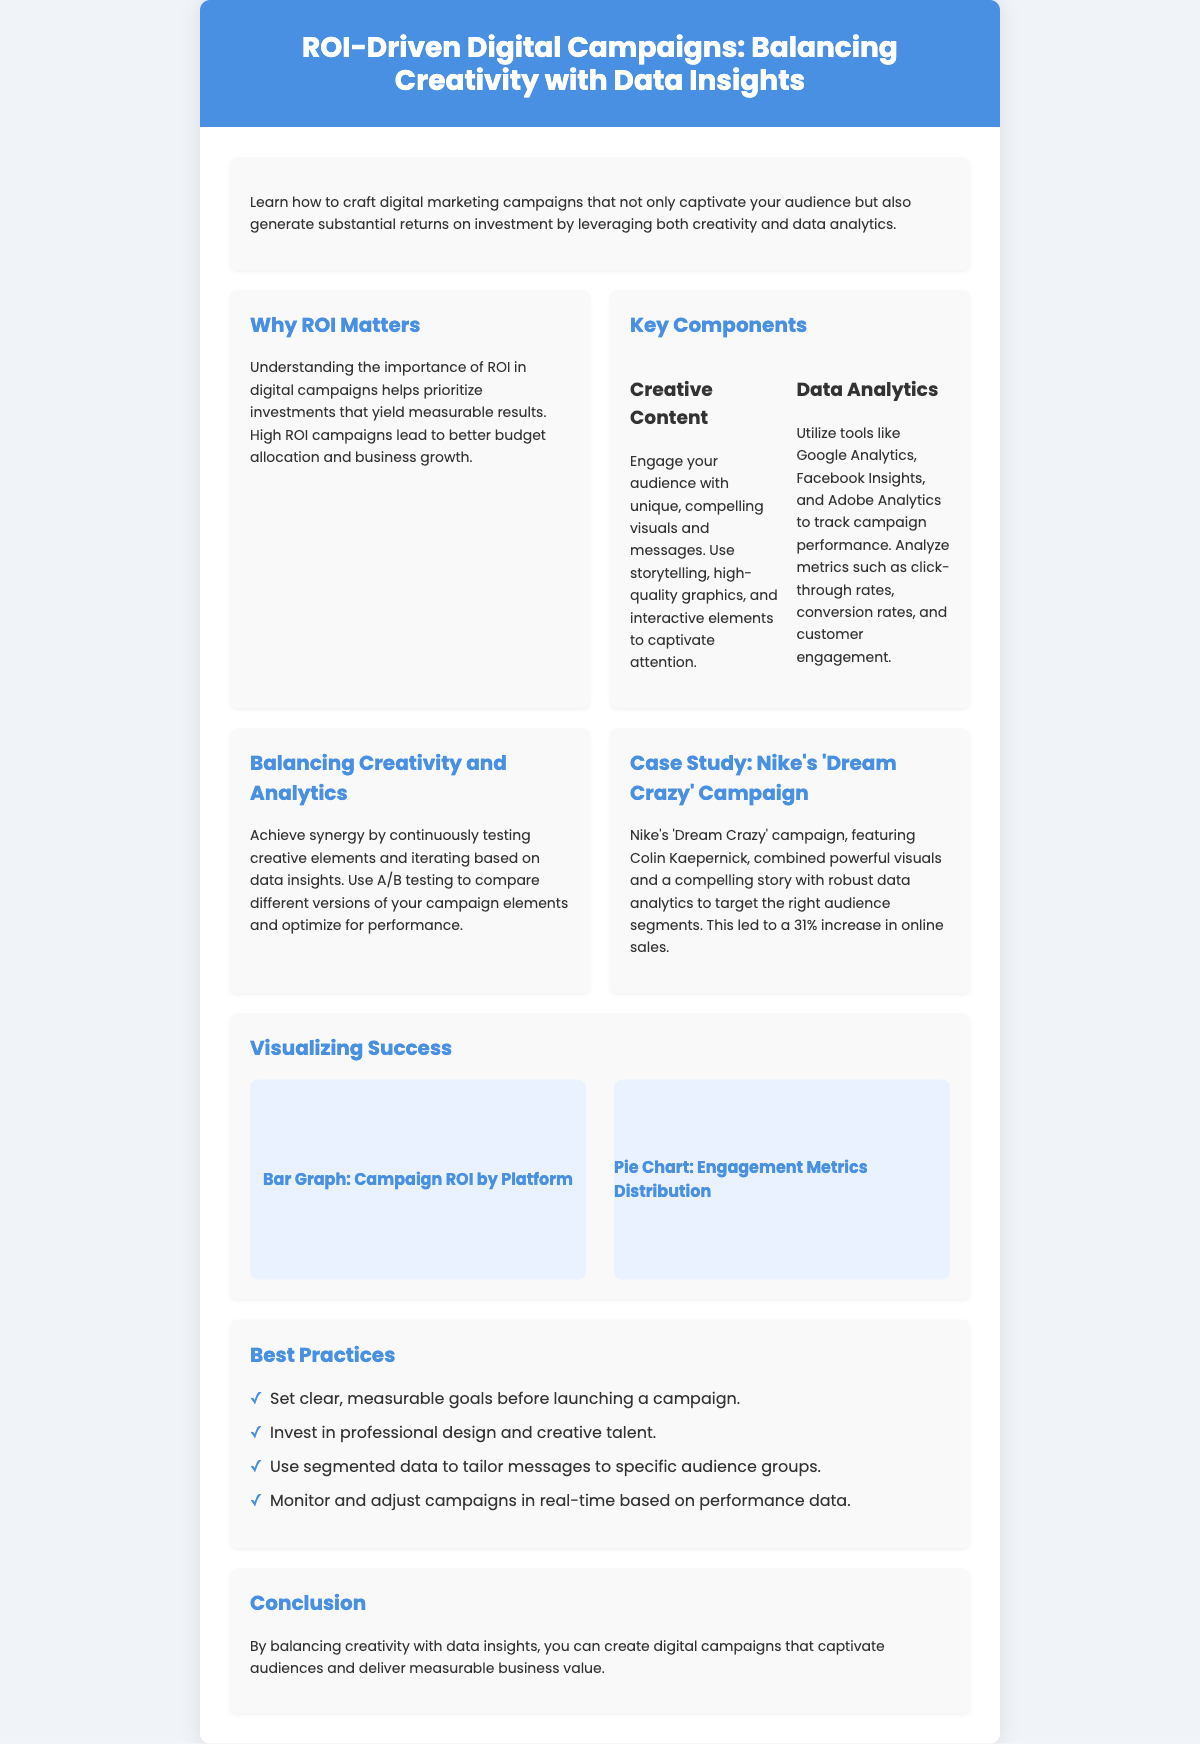What is the title of the poster? The title is stated at the top section of the poster.
Answer: ROI-Driven Digital Campaigns: Balancing Creativity with Data Insights What is the main focus of the poster? The poster highlights the synergy between creativity and data analytics in digital marketing campaigns.
Answer: Craft creative digital marketing campaigns backed by data analytics What campaign is used as a case study? The poster provides a specific example of a campaign that illustrates its points.
Answer: Nike's 'Dream Crazy' Campaign What percentage increase in online sales did Nike achieve? The case study provides a specific metric demonstrating the effectiveness of the campaign.
Answer: 31% What are two types of components mentioned in the poster? The poster lists essential components, emphasizing their importance in campaigns.
Answer: Creative Content and Data Analytics What should be done before launching a campaign? The best practices section indicates a necessary step for effective campaigning.
Answer: Set clear, measurable goals What visual representations are included in the poster? The section on visualizing success describes the types of information displayed.
Answer: Bar Graph and Pie Chart How does one achieve balance in campaigns according to the poster? The poster discusses methods to integrate the two focal areas effectively.
Answer: Continuously testing creative elements and iterating based on data insights What is the color of the header? The style choices in the poster are mentioned, which include colors.
Answer: #4a90e2 